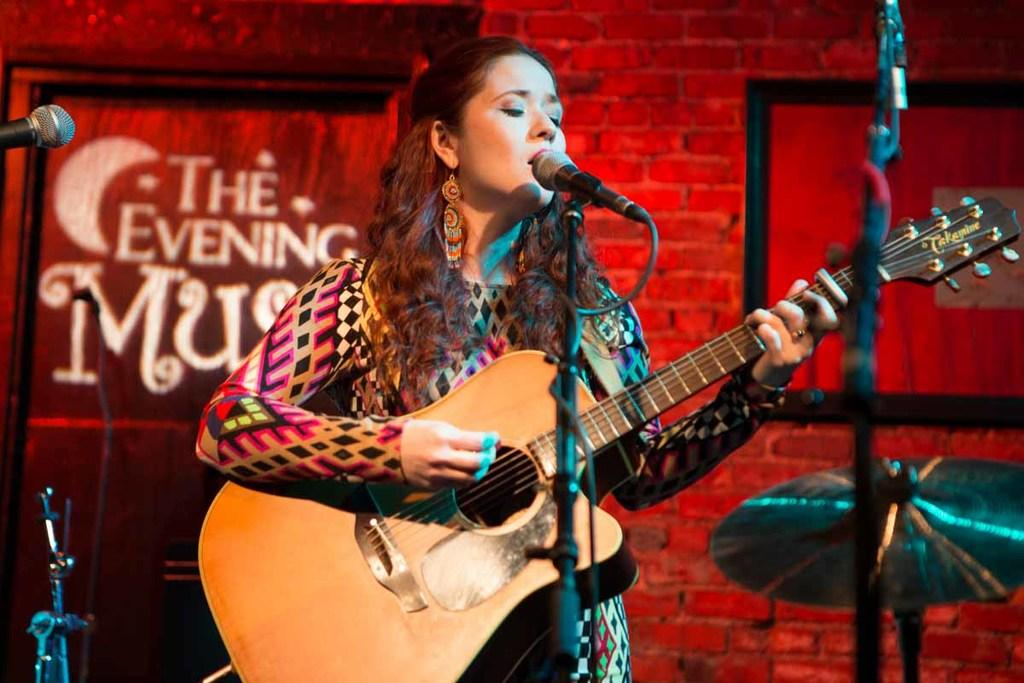What is the main subject of the image? The main subject of the image is a woman. What is the woman doing in the image? The woman is standing, holding a guitar, and singing. What is the woman using to amplify her voice? There is a microphone in front of the woman, and a stand associated with the microphone. What can be seen in the background of the image? There is a wall visible in the image. What type of nut can be seen on the wall in the image? There is no nut visible on the wall in the image. Is there an owl perched on the woman's shoulder in the image? No, there is no owl present in the image. 